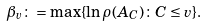<formula> <loc_0><loc_0><loc_500><loc_500>\beta _ { v } \colon = \max \{ \ln \rho ( A _ { C } ) \colon C \leq v \} .</formula> 